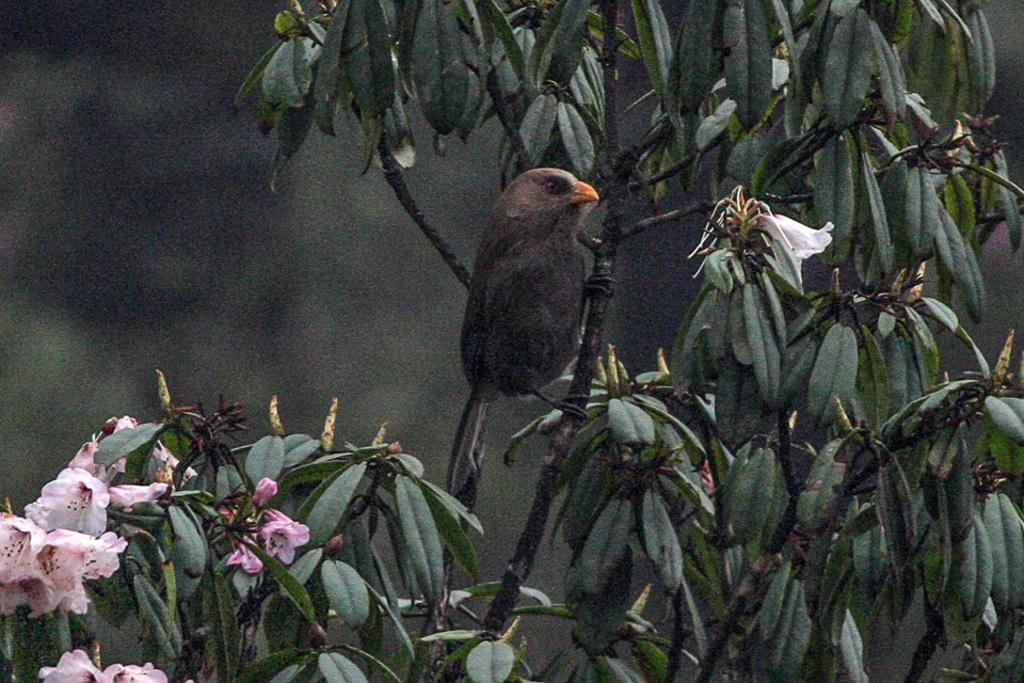What type of animal can be seen in the image? There is a bird in the image. Where is the bird located? The bird is on a tree in the image. What other elements are present in the image besides the bird? There are flowers in the image. What is the color of the flowers? The flowers are light pink in color. Who is the owner of the cherry that the bird is holding in the image? There is no cherry present in the image, and therefore no owner can be identified. Can you tell me how many donkeys are visible in the image? There are no donkeys present in the image. 